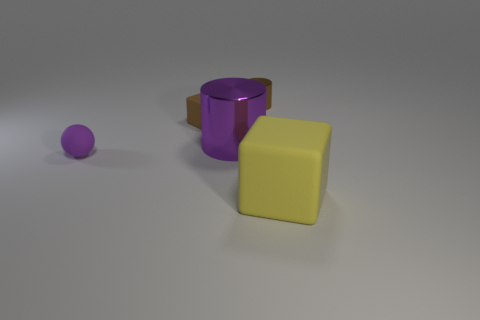What is the size of the thing that is the same color as the rubber sphere?
Ensure brevity in your answer.  Large. There is a rubber object that is the same color as the tiny metallic thing; what shape is it?
Your answer should be compact. Cube. There is a cube in front of the brown matte thing; how big is it?
Offer a very short reply. Large. Are there more brown cylinders than shiny cylinders?
Offer a very short reply. No. What material is the small brown block?
Provide a succinct answer. Rubber. How many other things are there of the same material as the tiny brown cylinder?
Make the answer very short. 1. How many big cylinders are there?
Provide a succinct answer. 1. What material is the other thing that is the same shape as the small brown metallic thing?
Your response must be concise. Metal. Is the material of the tiny sphere in front of the large metallic cylinder the same as the large cylinder?
Give a very brief answer. No. Are there more tiny brown things that are behind the small brown cube than small rubber balls that are right of the large yellow thing?
Your answer should be very brief. Yes. 